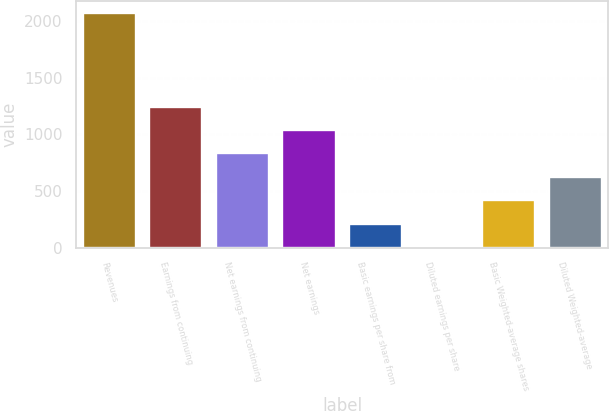Convert chart. <chart><loc_0><loc_0><loc_500><loc_500><bar_chart><fcel>Revenues<fcel>Earnings from continuing<fcel>Net earnings from continuing<fcel>Net earnings<fcel>Basic earnings per share from<fcel>Diluted earnings per share<fcel>Basic Weighted-average shares<fcel>Diluted Weighted-average<nl><fcel>2073<fcel>1244.42<fcel>830.14<fcel>1037.28<fcel>208.72<fcel>1.58<fcel>415.86<fcel>623<nl></chart> 